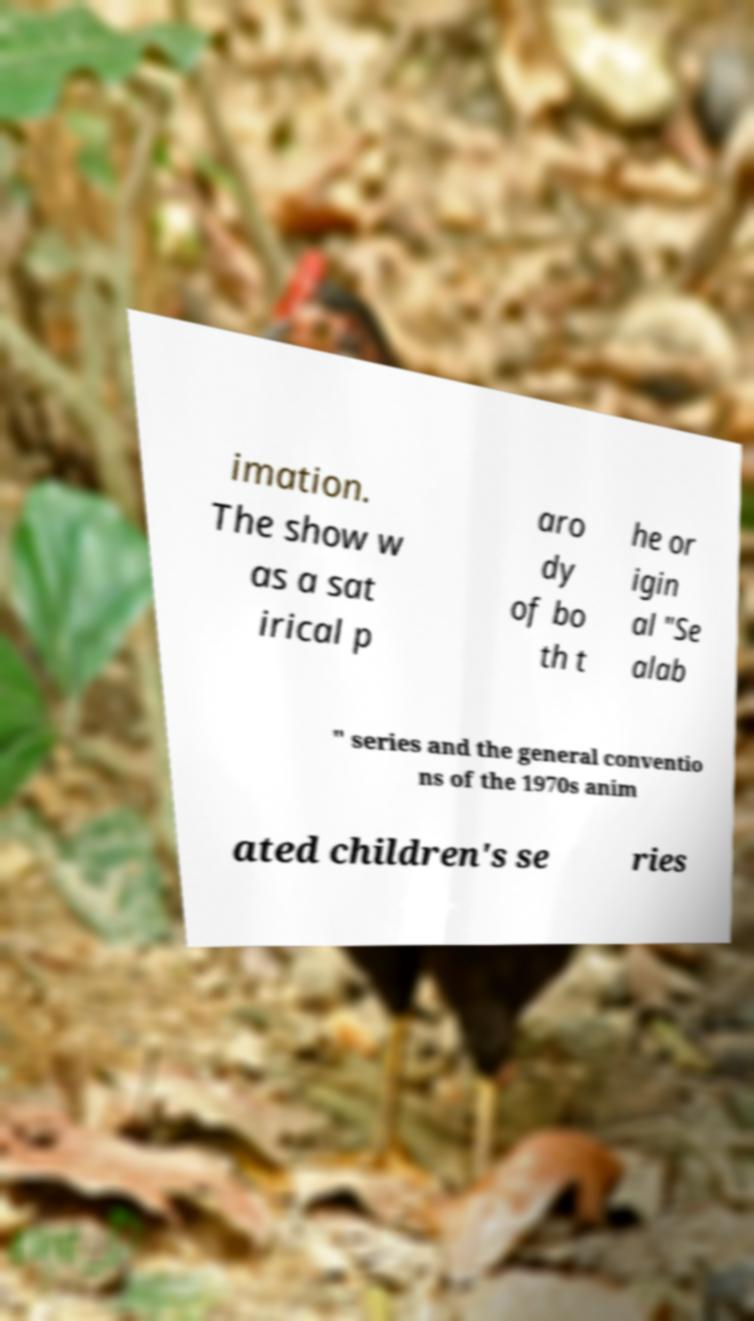Can you accurately transcribe the text from the provided image for me? imation. The show w as a sat irical p aro dy of bo th t he or igin al "Se alab " series and the general conventio ns of the 1970s anim ated children's se ries 